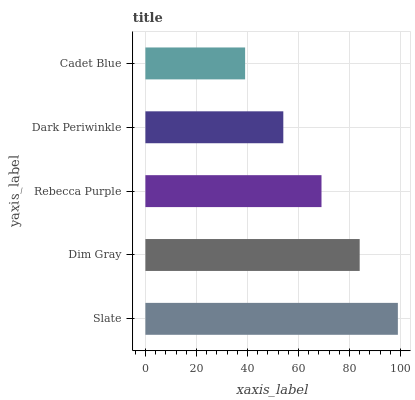Is Cadet Blue the minimum?
Answer yes or no. Yes. Is Slate the maximum?
Answer yes or no. Yes. Is Dim Gray the minimum?
Answer yes or no. No. Is Dim Gray the maximum?
Answer yes or no. No. Is Slate greater than Dim Gray?
Answer yes or no. Yes. Is Dim Gray less than Slate?
Answer yes or no. Yes. Is Dim Gray greater than Slate?
Answer yes or no. No. Is Slate less than Dim Gray?
Answer yes or no. No. Is Rebecca Purple the high median?
Answer yes or no. Yes. Is Rebecca Purple the low median?
Answer yes or no. Yes. Is Dim Gray the high median?
Answer yes or no. No. Is Cadet Blue the low median?
Answer yes or no. No. 